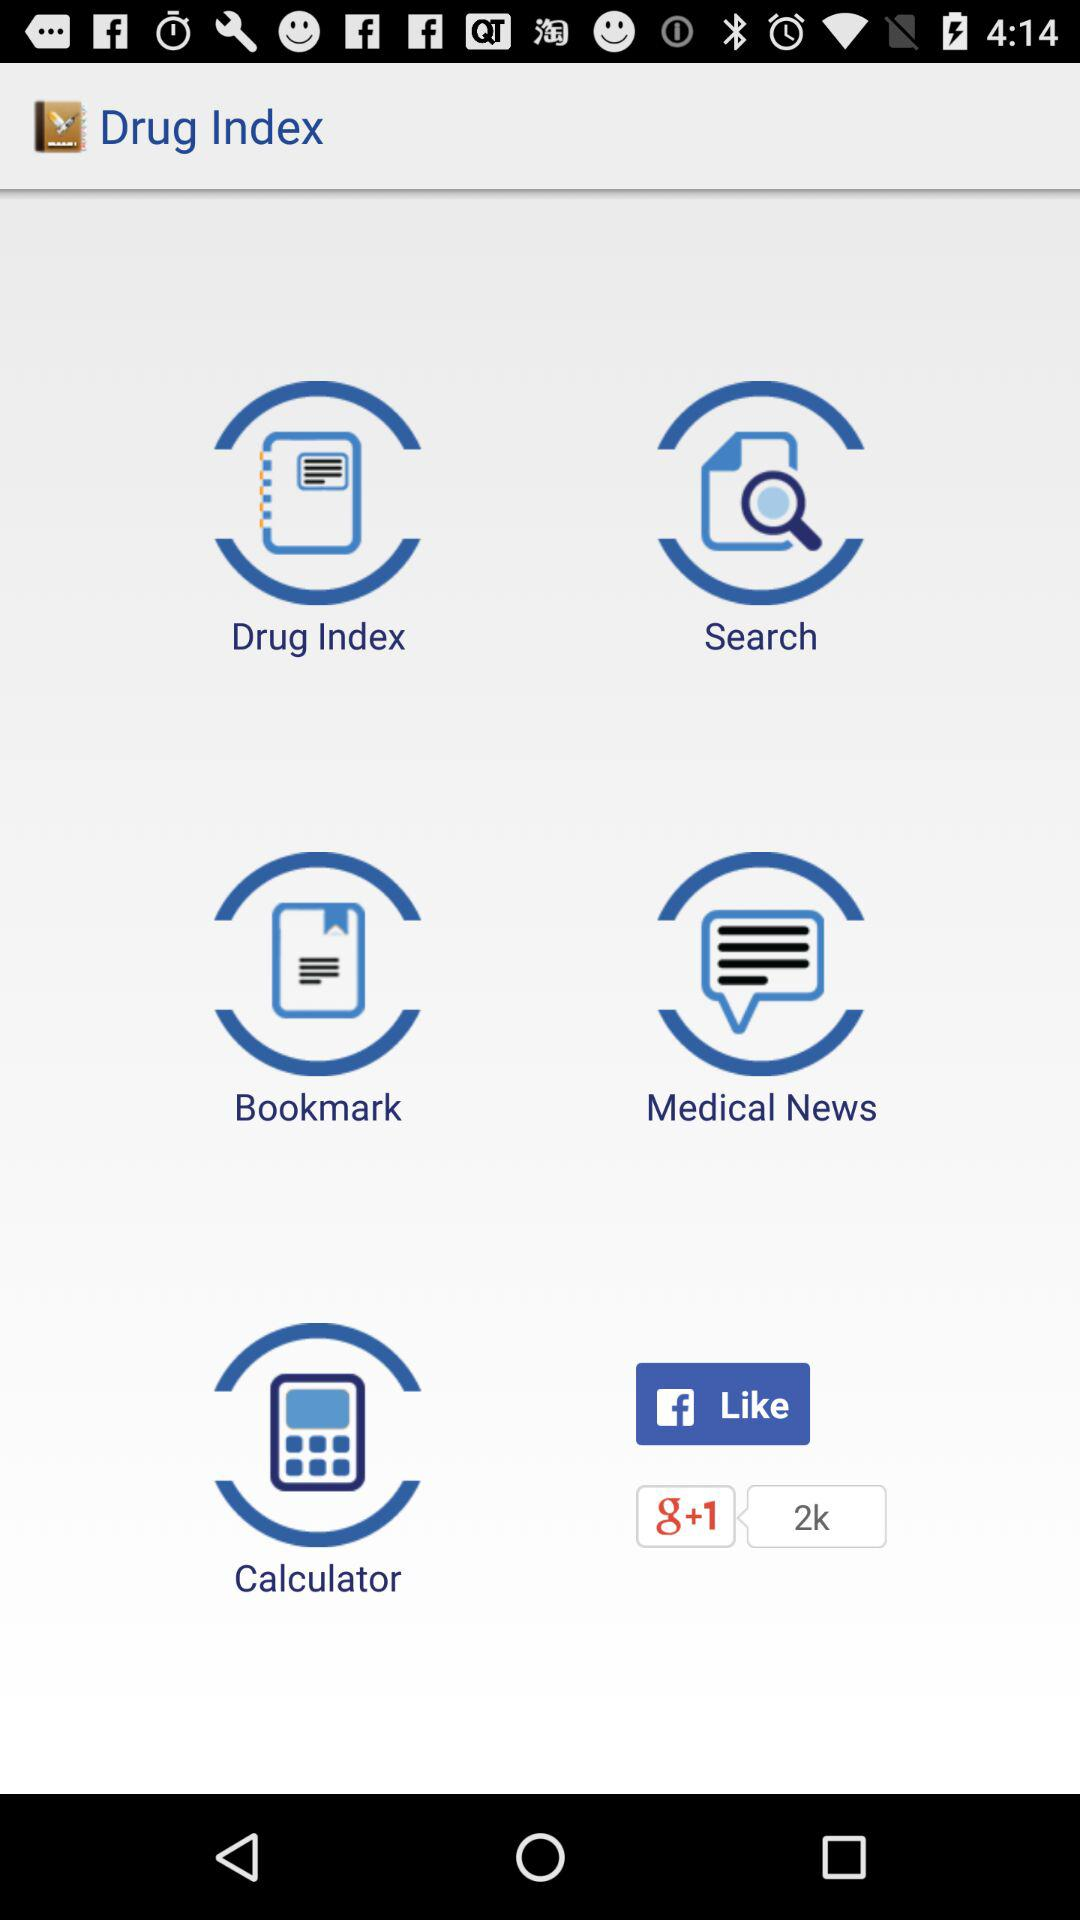Which drug indexes have been bookmarked?
When the provided information is insufficient, respond with <no answer>. <no answer> 